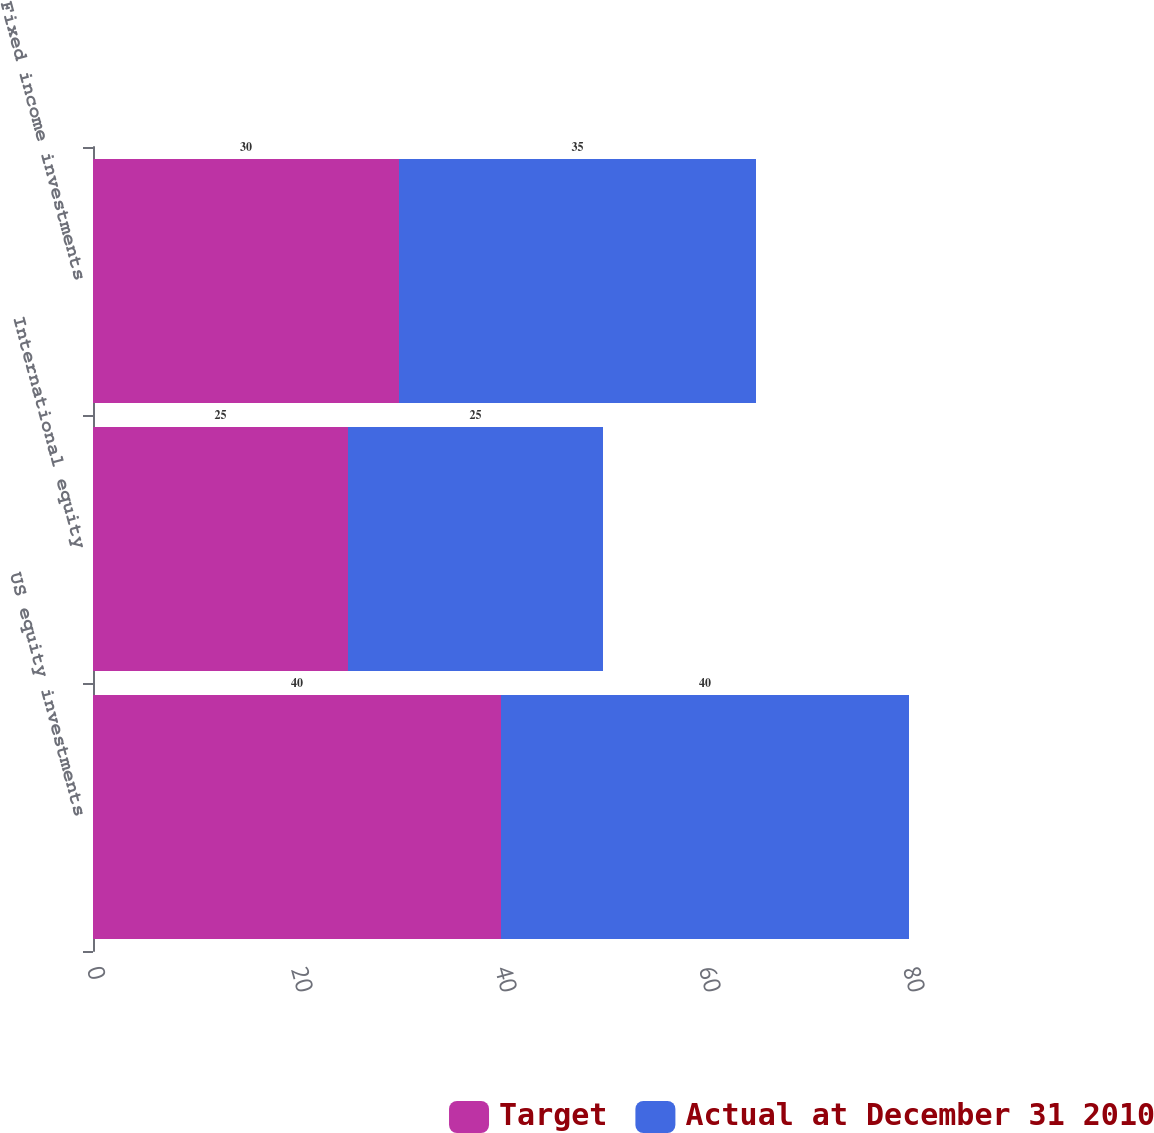Convert chart to OTSL. <chart><loc_0><loc_0><loc_500><loc_500><stacked_bar_chart><ecel><fcel>US equity investments<fcel>International equity<fcel>Fixed income investments<nl><fcel>Target<fcel>40<fcel>25<fcel>30<nl><fcel>Actual at December 31 2010<fcel>40<fcel>25<fcel>35<nl></chart> 